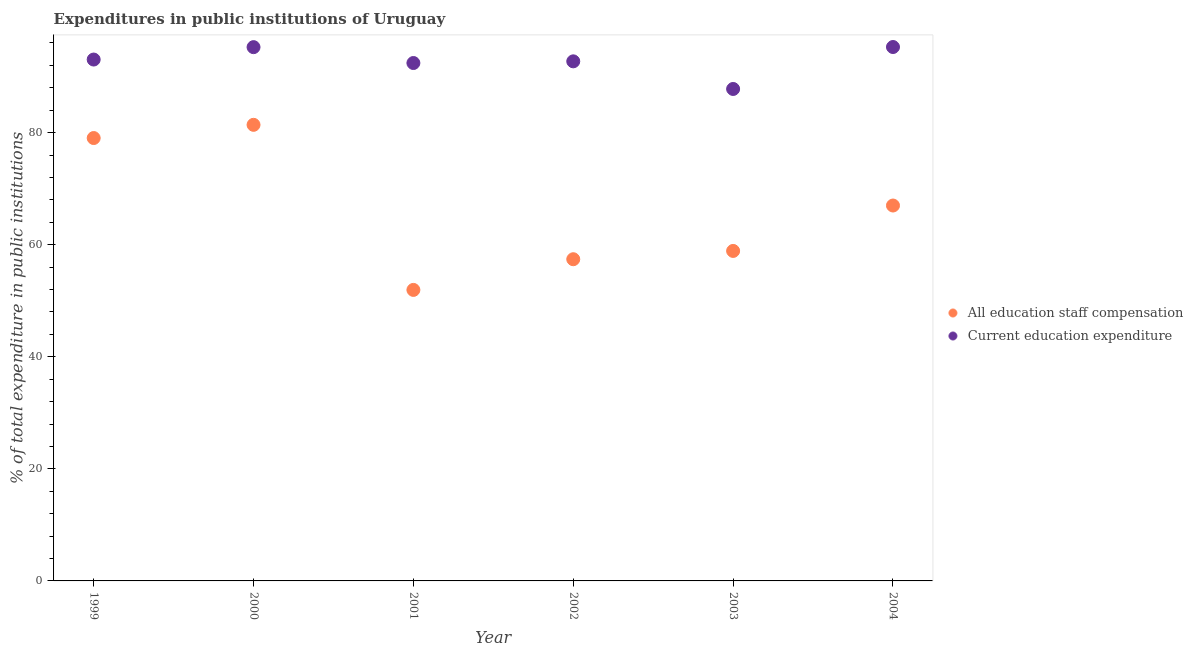How many different coloured dotlines are there?
Keep it short and to the point. 2. Is the number of dotlines equal to the number of legend labels?
Provide a succinct answer. Yes. What is the expenditure in education in 2003?
Offer a terse response. 87.79. Across all years, what is the maximum expenditure in education?
Your response must be concise. 95.28. Across all years, what is the minimum expenditure in staff compensation?
Your answer should be very brief. 51.93. In which year was the expenditure in education maximum?
Your response must be concise. 2004. In which year was the expenditure in staff compensation minimum?
Ensure brevity in your answer.  2001. What is the total expenditure in education in the graph?
Ensure brevity in your answer.  556.51. What is the difference between the expenditure in education in 2000 and that in 2002?
Your answer should be very brief. 2.53. What is the difference between the expenditure in education in 2003 and the expenditure in staff compensation in 2002?
Keep it short and to the point. 30.38. What is the average expenditure in education per year?
Give a very brief answer. 92.75. In the year 2004, what is the difference between the expenditure in staff compensation and expenditure in education?
Your answer should be very brief. -28.29. What is the ratio of the expenditure in staff compensation in 2003 to that in 2004?
Offer a terse response. 0.88. Is the expenditure in education in 1999 less than that in 2003?
Offer a very short reply. No. Is the difference between the expenditure in education in 1999 and 2002 greater than the difference between the expenditure in staff compensation in 1999 and 2002?
Ensure brevity in your answer.  No. What is the difference between the highest and the second highest expenditure in staff compensation?
Offer a very short reply. 2.36. What is the difference between the highest and the lowest expenditure in staff compensation?
Make the answer very short. 29.46. In how many years, is the expenditure in staff compensation greater than the average expenditure in staff compensation taken over all years?
Give a very brief answer. 3. Does the expenditure in staff compensation monotonically increase over the years?
Your response must be concise. No. How many years are there in the graph?
Make the answer very short. 6. Are the values on the major ticks of Y-axis written in scientific E-notation?
Your answer should be compact. No. How are the legend labels stacked?
Ensure brevity in your answer.  Vertical. What is the title of the graph?
Your answer should be compact. Expenditures in public institutions of Uruguay. Does "Males" appear as one of the legend labels in the graph?
Offer a very short reply. No. What is the label or title of the Y-axis?
Ensure brevity in your answer.  % of total expenditure in public institutions. What is the % of total expenditure in public institutions in All education staff compensation in 1999?
Your answer should be compact. 79.03. What is the % of total expenditure in public institutions of Current education expenditure in 1999?
Offer a very short reply. 93.04. What is the % of total expenditure in public institutions of All education staff compensation in 2000?
Offer a very short reply. 81.39. What is the % of total expenditure in public institutions of Current education expenditure in 2000?
Your response must be concise. 95.25. What is the % of total expenditure in public institutions in All education staff compensation in 2001?
Give a very brief answer. 51.93. What is the % of total expenditure in public institutions in Current education expenditure in 2001?
Give a very brief answer. 92.42. What is the % of total expenditure in public institutions in All education staff compensation in 2002?
Keep it short and to the point. 57.41. What is the % of total expenditure in public institutions of Current education expenditure in 2002?
Provide a succinct answer. 92.72. What is the % of total expenditure in public institutions of All education staff compensation in 2003?
Your response must be concise. 58.89. What is the % of total expenditure in public institutions in Current education expenditure in 2003?
Ensure brevity in your answer.  87.79. What is the % of total expenditure in public institutions in All education staff compensation in 2004?
Keep it short and to the point. 66.99. What is the % of total expenditure in public institutions in Current education expenditure in 2004?
Ensure brevity in your answer.  95.28. Across all years, what is the maximum % of total expenditure in public institutions in All education staff compensation?
Offer a terse response. 81.39. Across all years, what is the maximum % of total expenditure in public institutions of Current education expenditure?
Give a very brief answer. 95.28. Across all years, what is the minimum % of total expenditure in public institutions of All education staff compensation?
Provide a succinct answer. 51.93. Across all years, what is the minimum % of total expenditure in public institutions in Current education expenditure?
Make the answer very short. 87.79. What is the total % of total expenditure in public institutions in All education staff compensation in the graph?
Keep it short and to the point. 395.65. What is the total % of total expenditure in public institutions of Current education expenditure in the graph?
Ensure brevity in your answer.  556.51. What is the difference between the % of total expenditure in public institutions of All education staff compensation in 1999 and that in 2000?
Give a very brief answer. -2.36. What is the difference between the % of total expenditure in public institutions of Current education expenditure in 1999 and that in 2000?
Provide a short and direct response. -2.21. What is the difference between the % of total expenditure in public institutions of All education staff compensation in 1999 and that in 2001?
Make the answer very short. 27.1. What is the difference between the % of total expenditure in public institutions of Current education expenditure in 1999 and that in 2001?
Make the answer very short. 0.62. What is the difference between the % of total expenditure in public institutions of All education staff compensation in 1999 and that in 2002?
Ensure brevity in your answer.  21.63. What is the difference between the % of total expenditure in public institutions in Current education expenditure in 1999 and that in 2002?
Your response must be concise. 0.32. What is the difference between the % of total expenditure in public institutions in All education staff compensation in 1999 and that in 2003?
Offer a very short reply. 20.15. What is the difference between the % of total expenditure in public institutions in Current education expenditure in 1999 and that in 2003?
Your answer should be very brief. 5.25. What is the difference between the % of total expenditure in public institutions in All education staff compensation in 1999 and that in 2004?
Your answer should be compact. 12.04. What is the difference between the % of total expenditure in public institutions in Current education expenditure in 1999 and that in 2004?
Make the answer very short. -2.24. What is the difference between the % of total expenditure in public institutions in All education staff compensation in 2000 and that in 2001?
Keep it short and to the point. 29.46. What is the difference between the % of total expenditure in public institutions of Current education expenditure in 2000 and that in 2001?
Keep it short and to the point. 2.83. What is the difference between the % of total expenditure in public institutions in All education staff compensation in 2000 and that in 2002?
Provide a succinct answer. 23.98. What is the difference between the % of total expenditure in public institutions in Current education expenditure in 2000 and that in 2002?
Your answer should be compact. 2.53. What is the difference between the % of total expenditure in public institutions of All education staff compensation in 2000 and that in 2003?
Provide a succinct answer. 22.5. What is the difference between the % of total expenditure in public institutions in Current education expenditure in 2000 and that in 2003?
Ensure brevity in your answer.  7.46. What is the difference between the % of total expenditure in public institutions of All education staff compensation in 2000 and that in 2004?
Your answer should be very brief. 14.4. What is the difference between the % of total expenditure in public institutions of Current education expenditure in 2000 and that in 2004?
Offer a terse response. -0.02. What is the difference between the % of total expenditure in public institutions of All education staff compensation in 2001 and that in 2002?
Your response must be concise. -5.48. What is the difference between the % of total expenditure in public institutions in Current education expenditure in 2001 and that in 2002?
Ensure brevity in your answer.  -0.3. What is the difference between the % of total expenditure in public institutions in All education staff compensation in 2001 and that in 2003?
Your answer should be compact. -6.96. What is the difference between the % of total expenditure in public institutions in Current education expenditure in 2001 and that in 2003?
Provide a short and direct response. 4.63. What is the difference between the % of total expenditure in public institutions of All education staff compensation in 2001 and that in 2004?
Offer a very short reply. -15.06. What is the difference between the % of total expenditure in public institutions of Current education expenditure in 2001 and that in 2004?
Your response must be concise. -2.86. What is the difference between the % of total expenditure in public institutions in All education staff compensation in 2002 and that in 2003?
Give a very brief answer. -1.48. What is the difference between the % of total expenditure in public institutions in Current education expenditure in 2002 and that in 2003?
Provide a succinct answer. 4.93. What is the difference between the % of total expenditure in public institutions in All education staff compensation in 2002 and that in 2004?
Offer a very short reply. -9.58. What is the difference between the % of total expenditure in public institutions in Current education expenditure in 2002 and that in 2004?
Give a very brief answer. -2.56. What is the difference between the % of total expenditure in public institutions of All education staff compensation in 2003 and that in 2004?
Provide a succinct answer. -8.1. What is the difference between the % of total expenditure in public institutions of Current education expenditure in 2003 and that in 2004?
Your answer should be very brief. -7.49. What is the difference between the % of total expenditure in public institutions in All education staff compensation in 1999 and the % of total expenditure in public institutions in Current education expenditure in 2000?
Your response must be concise. -16.22. What is the difference between the % of total expenditure in public institutions of All education staff compensation in 1999 and the % of total expenditure in public institutions of Current education expenditure in 2001?
Make the answer very short. -13.39. What is the difference between the % of total expenditure in public institutions of All education staff compensation in 1999 and the % of total expenditure in public institutions of Current education expenditure in 2002?
Offer a very short reply. -13.69. What is the difference between the % of total expenditure in public institutions in All education staff compensation in 1999 and the % of total expenditure in public institutions in Current education expenditure in 2003?
Provide a short and direct response. -8.76. What is the difference between the % of total expenditure in public institutions of All education staff compensation in 1999 and the % of total expenditure in public institutions of Current education expenditure in 2004?
Your answer should be very brief. -16.24. What is the difference between the % of total expenditure in public institutions of All education staff compensation in 2000 and the % of total expenditure in public institutions of Current education expenditure in 2001?
Offer a terse response. -11.03. What is the difference between the % of total expenditure in public institutions in All education staff compensation in 2000 and the % of total expenditure in public institutions in Current education expenditure in 2002?
Provide a short and direct response. -11.33. What is the difference between the % of total expenditure in public institutions in All education staff compensation in 2000 and the % of total expenditure in public institutions in Current education expenditure in 2003?
Your answer should be very brief. -6.4. What is the difference between the % of total expenditure in public institutions in All education staff compensation in 2000 and the % of total expenditure in public institutions in Current education expenditure in 2004?
Your answer should be compact. -13.89. What is the difference between the % of total expenditure in public institutions in All education staff compensation in 2001 and the % of total expenditure in public institutions in Current education expenditure in 2002?
Your answer should be very brief. -40.79. What is the difference between the % of total expenditure in public institutions in All education staff compensation in 2001 and the % of total expenditure in public institutions in Current education expenditure in 2003?
Give a very brief answer. -35.86. What is the difference between the % of total expenditure in public institutions of All education staff compensation in 2001 and the % of total expenditure in public institutions of Current education expenditure in 2004?
Keep it short and to the point. -43.35. What is the difference between the % of total expenditure in public institutions of All education staff compensation in 2002 and the % of total expenditure in public institutions of Current education expenditure in 2003?
Offer a very short reply. -30.38. What is the difference between the % of total expenditure in public institutions in All education staff compensation in 2002 and the % of total expenditure in public institutions in Current education expenditure in 2004?
Provide a succinct answer. -37.87. What is the difference between the % of total expenditure in public institutions of All education staff compensation in 2003 and the % of total expenditure in public institutions of Current education expenditure in 2004?
Your answer should be compact. -36.39. What is the average % of total expenditure in public institutions in All education staff compensation per year?
Provide a succinct answer. 65.94. What is the average % of total expenditure in public institutions of Current education expenditure per year?
Your response must be concise. 92.75. In the year 1999, what is the difference between the % of total expenditure in public institutions in All education staff compensation and % of total expenditure in public institutions in Current education expenditure?
Your response must be concise. -14.01. In the year 2000, what is the difference between the % of total expenditure in public institutions of All education staff compensation and % of total expenditure in public institutions of Current education expenditure?
Ensure brevity in your answer.  -13.86. In the year 2001, what is the difference between the % of total expenditure in public institutions in All education staff compensation and % of total expenditure in public institutions in Current education expenditure?
Keep it short and to the point. -40.49. In the year 2002, what is the difference between the % of total expenditure in public institutions of All education staff compensation and % of total expenditure in public institutions of Current education expenditure?
Provide a succinct answer. -35.31. In the year 2003, what is the difference between the % of total expenditure in public institutions in All education staff compensation and % of total expenditure in public institutions in Current education expenditure?
Offer a very short reply. -28.9. In the year 2004, what is the difference between the % of total expenditure in public institutions of All education staff compensation and % of total expenditure in public institutions of Current education expenditure?
Make the answer very short. -28.29. What is the ratio of the % of total expenditure in public institutions of Current education expenditure in 1999 to that in 2000?
Provide a short and direct response. 0.98. What is the ratio of the % of total expenditure in public institutions in All education staff compensation in 1999 to that in 2001?
Provide a short and direct response. 1.52. What is the ratio of the % of total expenditure in public institutions of All education staff compensation in 1999 to that in 2002?
Give a very brief answer. 1.38. What is the ratio of the % of total expenditure in public institutions in Current education expenditure in 1999 to that in 2002?
Provide a short and direct response. 1. What is the ratio of the % of total expenditure in public institutions in All education staff compensation in 1999 to that in 2003?
Give a very brief answer. 1.34. What is the ratio of the % of total expenditure in public institutions in Current education expenditure in 1999 to that in 2003?
Offer a very short reply. 1.06. What is the ratio of the % of total expenditure in public institutions in All education staff compensation in 1999 to that in 2004?
Make the answer very short. 1.18. What is the ratio of the % of total expenditure in public institutions of Current education expenditure in 1999 to that in 2004?
Make the answer very short. 0.98. What is the ratio of the % of total expenditure in public institutions in All education staff compensation in 2000 to that in 2001?
Your answer should be very brief. 1.57. What is the ratio of the % of total expenditure in public institutions of Current education expenditure in 2000 to that in 2001?
Ensure brevity in your answer.  1.03. What is the ratio of the % of total expenditure in public institutions of All education staff compensation in 2000 to that in 2002?
Offer a terse response. 1.42. What is the ratio of the % of total expenditure in public institutions of Current education expenditure in 2000 to that in 2002?
Ensure brevity in your answer.  1.03. What is the ratio of the % of total expenditure in public institutions of All education staff compensation in 2000 to that in 2003?
Offer a terse response. 1.38. What is the ratio of the % of total expenditure in public institutions of Current education expenditure in 2000 to that in 2003?
Make the answer very short. 1.08. What is the ratio of the % of total expenditure in public institutions of All education staff compensation in 2000 to that in 2004?
Your response must be concise. 1.22. What is the ratio of the % of total expenditure in public institutions in Current education expenditure in 2000 to that in 2004?
Provide a short and direct response. 1. What is the ratio of the % of total expenditure in public institutions in All education staff compensation in 2001 to that in 2002?
Provide a succinct answer. 0.9. What is the ratio of the % of total expenditure in public institutions of All education staff compensation in 2001 to that in 2003?
Offer a very short reply. 0.88. What is the ratio of the % of total expenditure in public institutions in Current education expenditure in 2001 to that in 2003?
Your answer should be compact. 1.05. What is the ratio of the % of total expenditure in public institutions in All education staff compensation in 2001 to that in 2004?
Your answer should be very brief. 0.78. What is the ratio of the % of total expenditure in public institutions in Current education expenditure in 2001 to that in 2004?
Your answer should be compact. 0.97. What is the ratio of the % of total expenditure in public institutions in All education staff compensation in 2002 to that in 2003?
Make the answer very short. 0.97. What is the ratio of the % of total expenditure in public institutions in Current education expenditure in 2002 to that in 2003?
Provide a succinct answer. 1.06. What is the ratio of the % of total expenditure in public institutions of All education staff compensation in 2002 to that in 2004?
Ensure brevity in your answer.  0.86. What is the ratio of the % of total expenditure in public institutions in Current education expenditure in 2002 to that in 2004?
Your answer should be very brief. 0.97. What is the ratio of the % of total expenditure in public institutions of All education staff compensation in 2003 to that in 2004?
Your answer should be very brief. 0.88. What is the ratio of the % of total expenditure in public institutions in Current education expenditure in 2003 to that in 2004?
Your answer should be very brief. 0.92. What is the difference between the highest and the second highest % of total expenditure in public institutions of All education staff compensation?
Provide a short and direct response. 2.36. What is the difference between the highest and the second highest % of total expenditure in public institutions of Current education expenditure?
Make the answer very short. 0.02. What is the difference between the highest and the lowest % of total expenditure in public institutions in All education staff compensation?
Offer a very short reply. 29.46. What is the difference between the highest and the lowest % of total expenditure in public institutions of Current education expenditure?
Your answer should be compact. 7.49. 